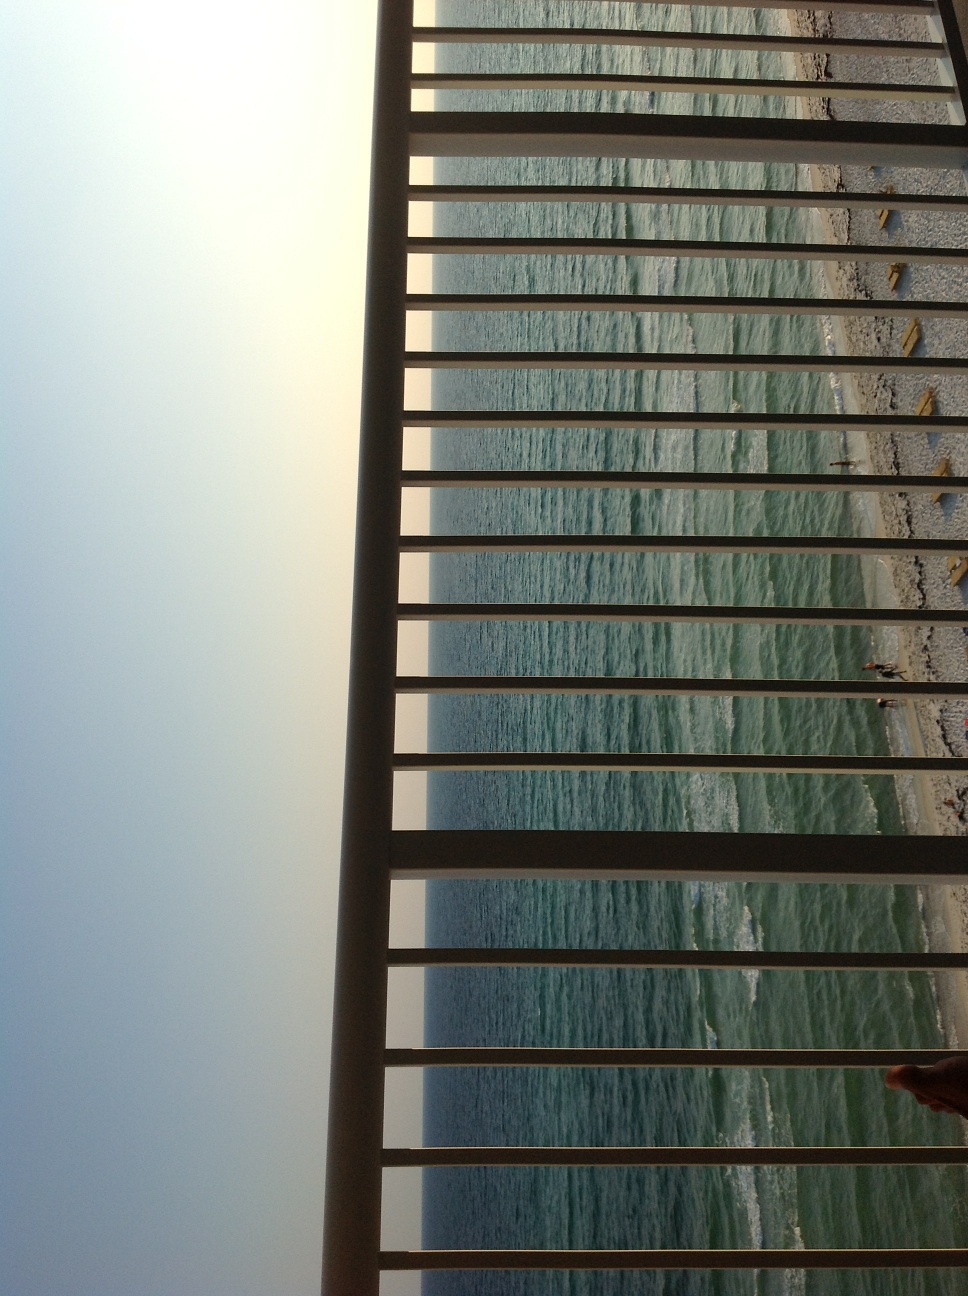What might be the significance of the railing in this picture? The railing in the picture adds both an aesthetic and practical element. Structurally, it introduces a foreground that gives depth and contrast against the backdrop of the wide, open sea. Symbolically, it can represent a boundary or a safety barrier, inviting viewers to peer through to the expansive ocean beyond while providing a sense of security. 